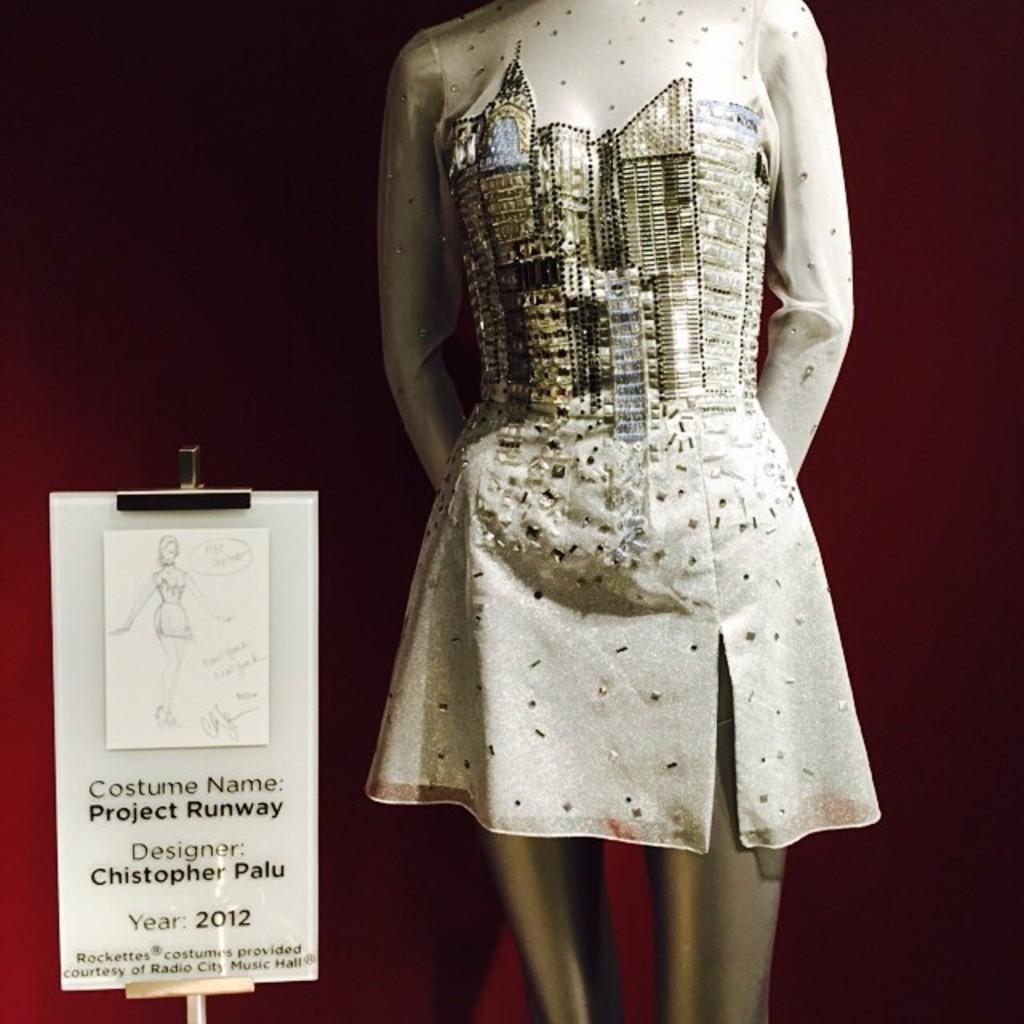Can you describe this image briefly? It is the dress to the doll. On the left side there is a board, which describing about this dress. 